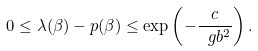<formula> <loc_0><loc_0><loc_500><loc_500>0 \leq \lambda ( \beta ) - p ( \beta ) \leq \exp \left ( - \frac { c } { \ g b ^ { 2 } } \right ) .</formula> 